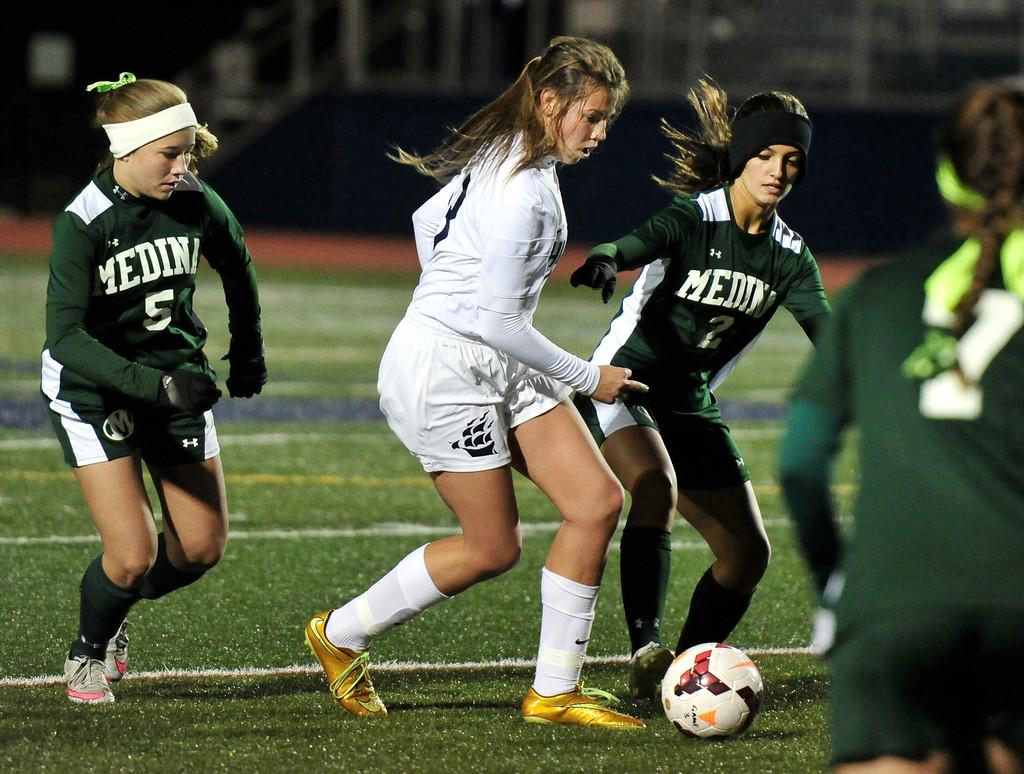How many people are in the image? There are four persons in the image. What are the persons doing in the image? The persons are playing with a ball. What is the surface they are playing on? The ground is grassy. What type of beetle can be seen crawling on the lamp in the image? There is no beetle or lamp present in the image; it features four persons playing with a ball on a grassy surface. 